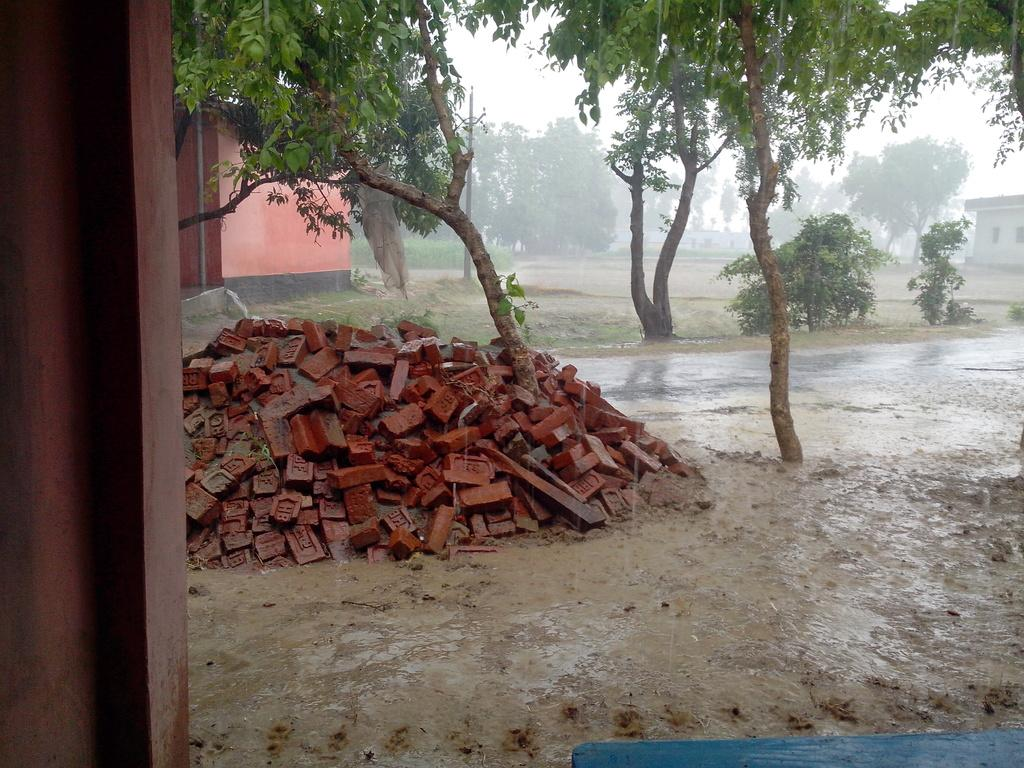What is located on the left side of the image? There is a heap of bricks on the left side of the image. What can be seen in the background of the image? There are trees, a pole, buildings, and the sky visible in the background of the image. What is the name of the person standing next to the pole in the image? There is no person standing next to the pole in the image. How does the wind affect the trees in the image? The image does not show any movement of the trees, so it cannot be determined how the wind affects them. 